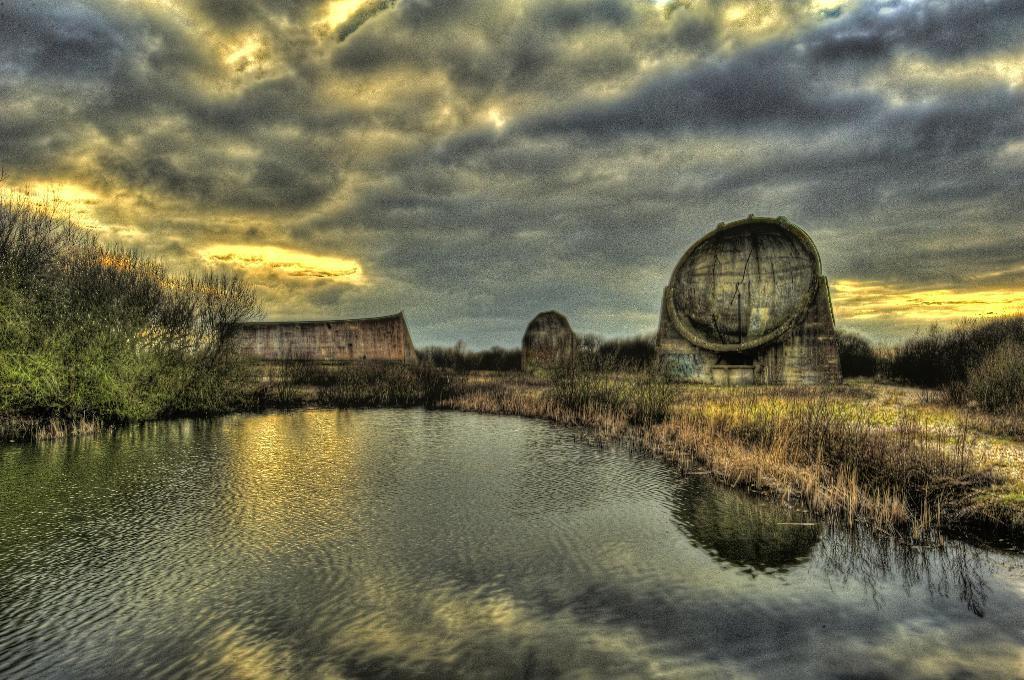How would you summarize this image in a sentence or two? In this image, we can see a lake. There is a building and dome in the middle of the image. There are some plants on the left and on the right side of the image. There are clouds in the sky. 